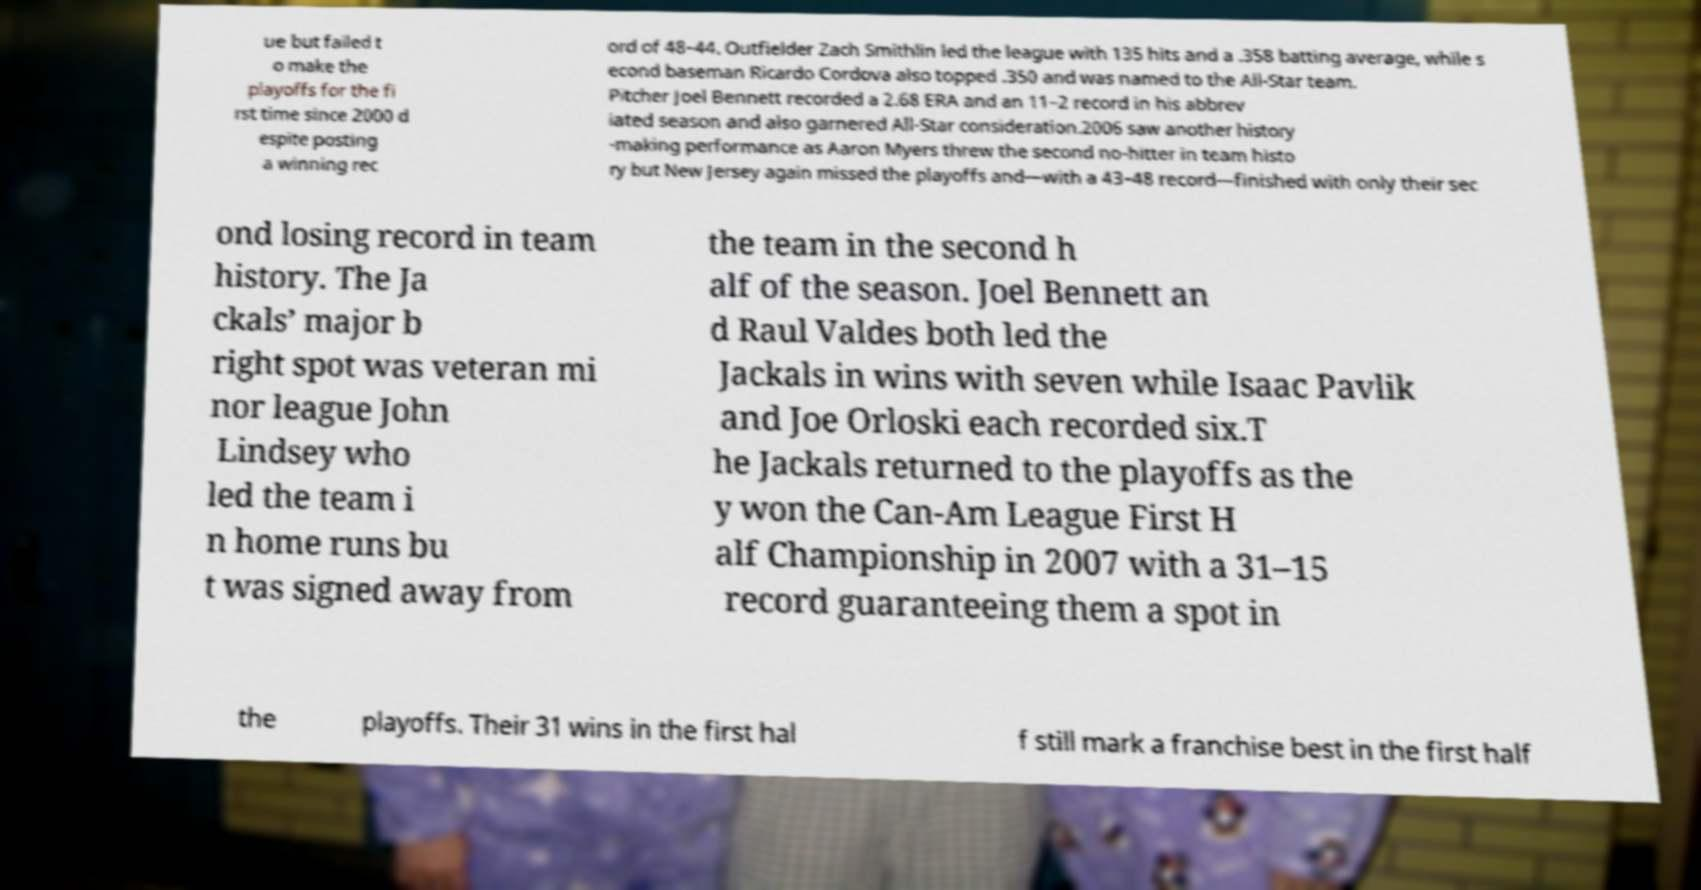For documentation purposes, I need the text within this image transcribed. Could you provide that? ue but failed t o make the playoffs for the fi rst time since 2000 d espite posting a winning rec ord of 48–44. Outfielder Zach Smithlin led the league with 135 hits and a .358 batting average, while s econd baseman Ricardo Cordova also topped .350 and was named to the All-Star team. Pitcher Joel Bennett recorded a 2.68 ERA and an 11–2 record in his abbrev iated season and also garnered All-Star consideration.2006 saw another history -making performance as Aaron Myers threw the second no-hitter in team histo ry but New Jersey again missed the playoffs and—with a 43–48 record—finished with only their sec ond losing record in team history. The Ja ckals’ major b right spot was veteran mi nor league John Lindsey who led the team i n home runs bu t was signed away from the team in the second h alf of the season. Joel Bennett an d Raul Valdes both led the Jackals in wins with seven while Isaac Pavlik and Joe Orloski each recorded six.T he Jackals returned to the playoffs as the y won the Can-Am League First H alf Championship in 2007 with a 31–15 record guaranteeing them a spot in the playoffs. Their 31 wins in the first hal f still mark a franchise best in the first half 